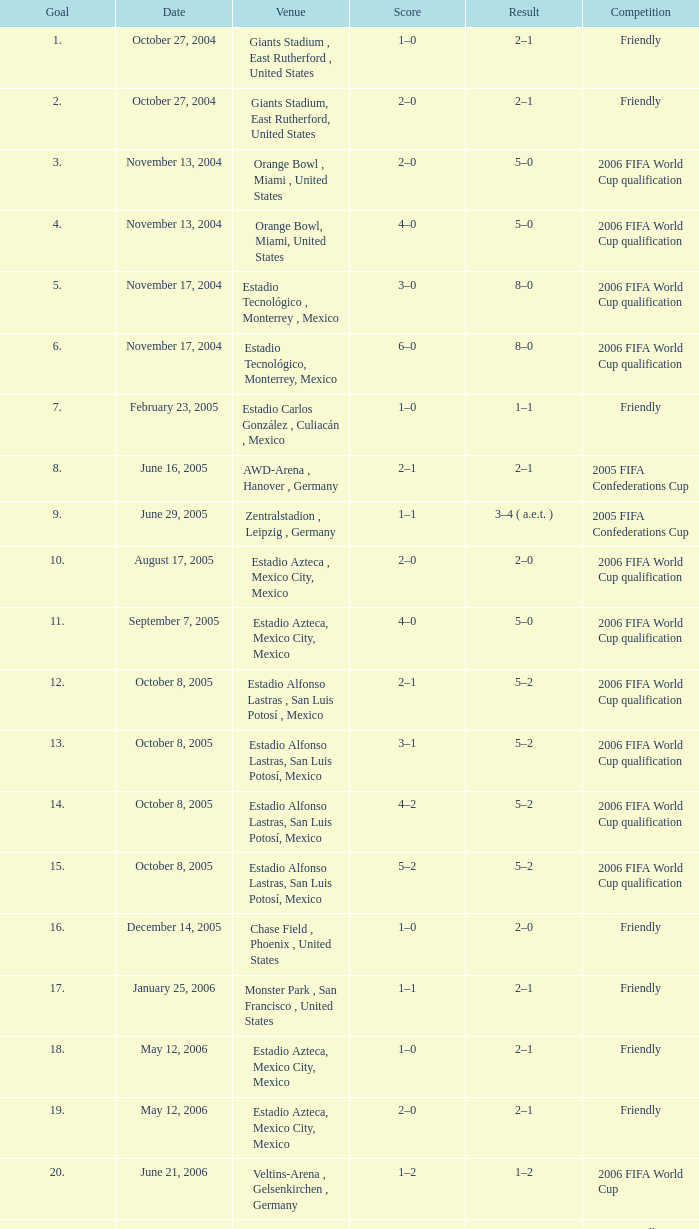Which score has a consequence of 2-1, and a tournament of friendly, and a goal below 17? 1–0, 2–0. 